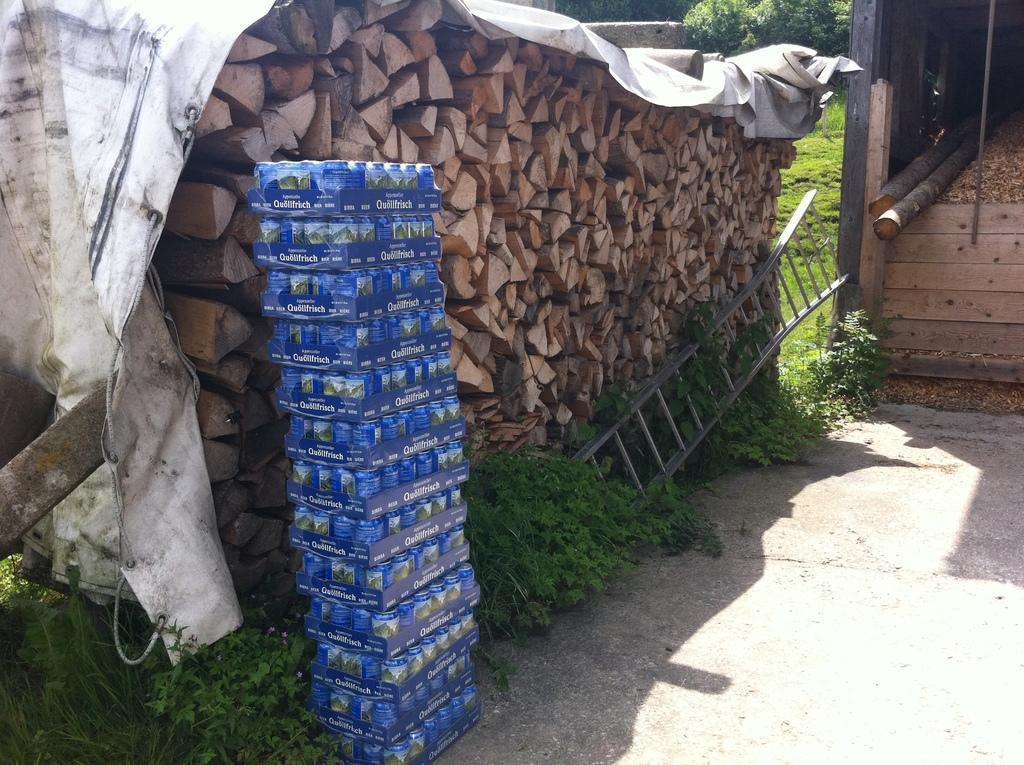Can you describe this image briefly? In a given image I can see a wooden objects, ladder, plants, grass and some other objects. 